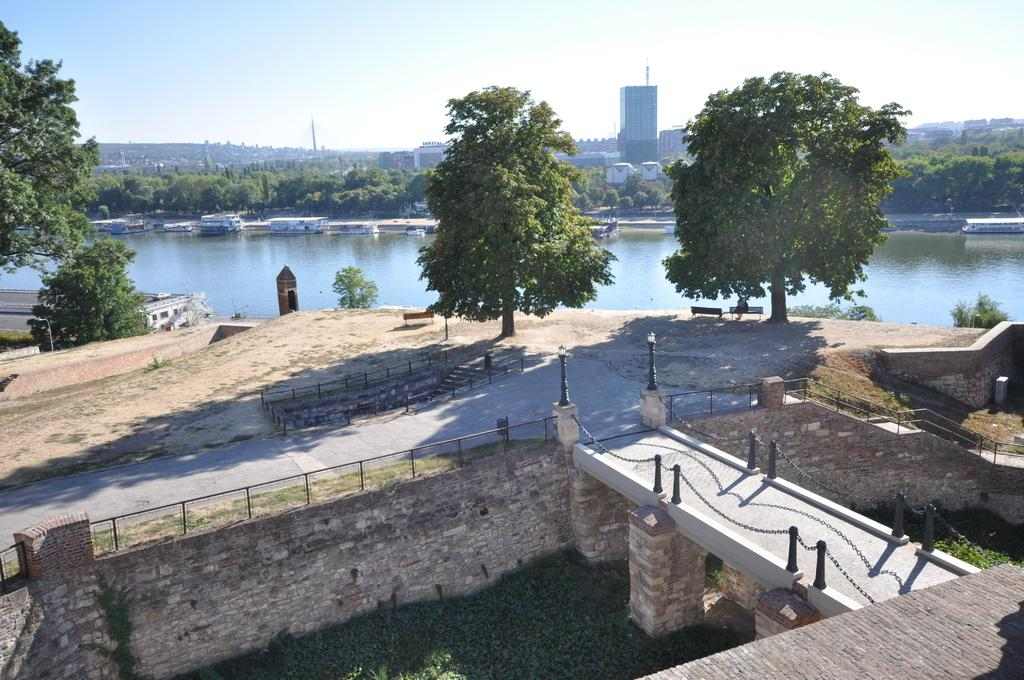What is the main feature in the center of the image? There is a lake in the center of the image. What is on the lake? There are boats on the lake. What type of vegetation can be seen in the image? There are trees visible in the image. What architectural feature is at the bottom of the image? There is a bridge at the bottom of the image. What structures can be seen in the distance? There are buildings in the background of the image. What part of the natural environment is visible in the image? The sky is visible in the background of the image. What type of plot is being discussed in the image? There is no discussion or plot present in the image; it is a visual representation of a lake, boats, trees, a bridge, buildings, and the sky. 